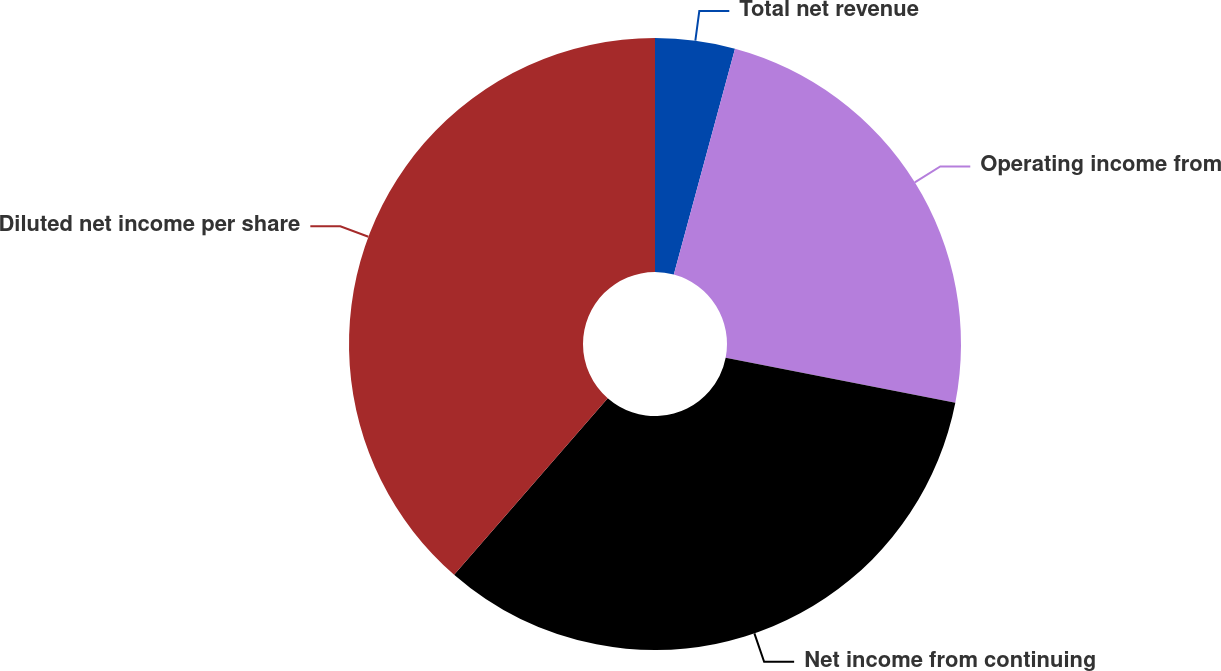<chart> <loc_0><loc_0><loc_500><loc_500><pie_chart><fcel>Total net revenue<fcel>Operating income from<fcel>Net income from continuing<fcel>Diluted net income per share<nl><fcel>4.21%<fcel>23.86%<fcel>33.33%<fcel>38.6%<nl></chart> 